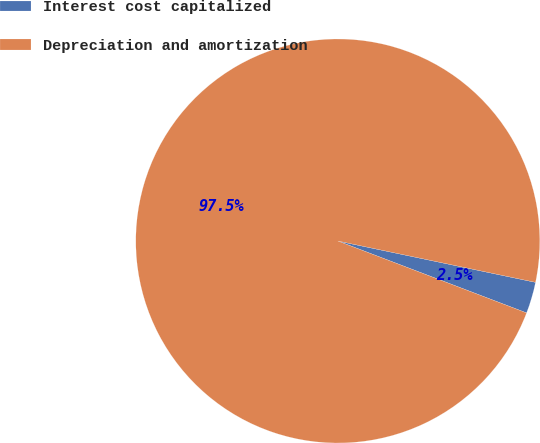Convert chart to OTSL. <chart><loc_0><loc_0><loc_500><loc_500><pie_chart><fcel>Interest cost capitalized<fcel>Depreciation and amortization<nl><fcel>2.51%<fcel>97.49%<nl></chart> 